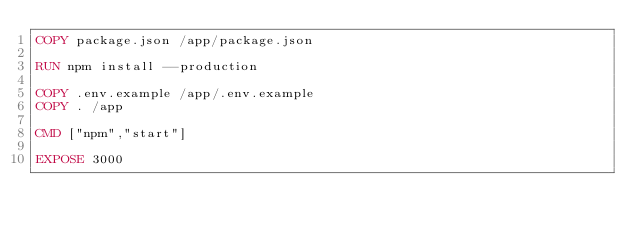Convert code to text. <code><loc_0><loc_0><loc_500><loc_500><_Dockerfile_>COPY package.json /app/package.json

RUN npm install --production

COPY .env.example /app/.env.example
COPY . /app

CMD ["npm","start"]

EXPOSE 3000
</code> 